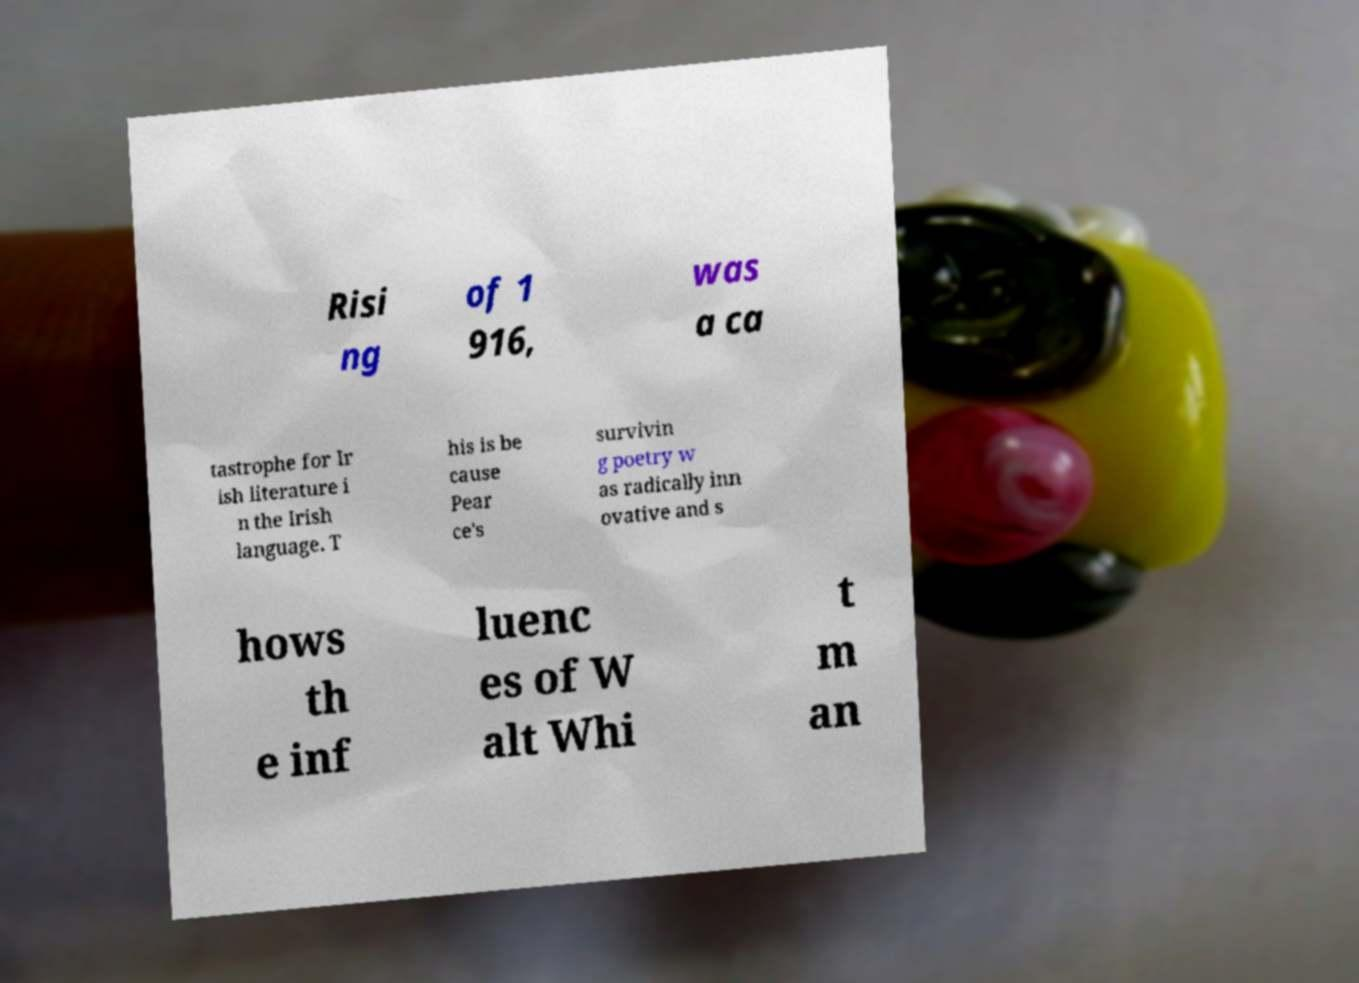For documentation purposes, I need the text within this image transcribed. Could you provide that? Risi ng of 1 916, was a ca tastrophe for Ir ish literature i n the Irish language. T his is be cause Pear ce's survivin g poetry w as radically inn ovative and s hows th e inf luenc es of W alt Whi t m an 